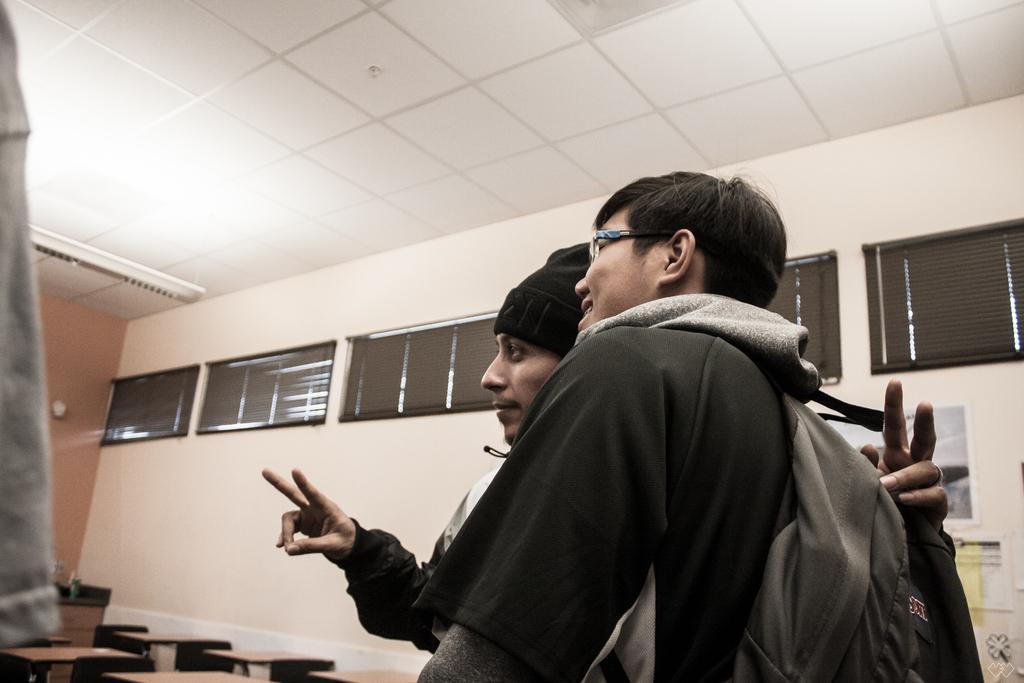Describe this image in one or two sentences. In this picture there is a man who is wearing, spectacle, jacket and bag. Beside him there is another man who is showing his two fingers from his hand. At the bottom i can see many table and bench. On the right i can see many black exhaust wings, beside that i can see the posters on the wall. On the left i can see the tube light. 